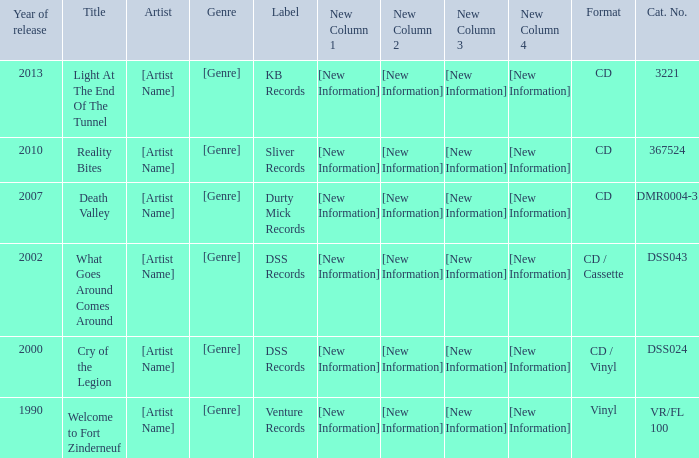What is the latest year of the album with the release title death valley? 2007.0. 